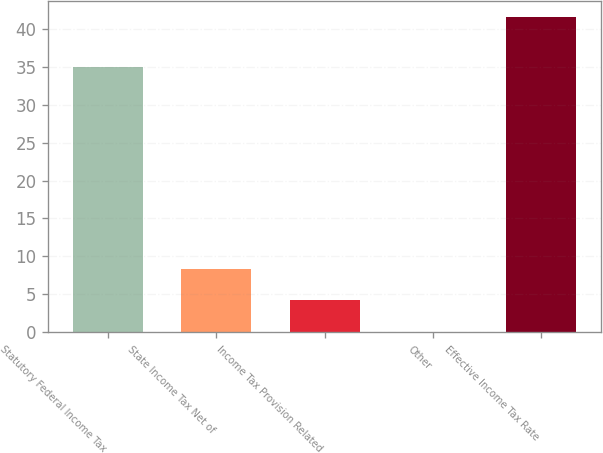<chart> <loc_0><loc_0><loc_500><loc_500><bar_chart><fcel>Statutory Federal Income Tax<fcel>State Income Tax Net of<fcel>Income Tax Provision Related<fcel>Other<fcel>Effective Income Tax Rate<nl><fcel>35<fcel>8.35<fcel>4.19<fcel>0.03<fcel>41.64<nl></chart> 